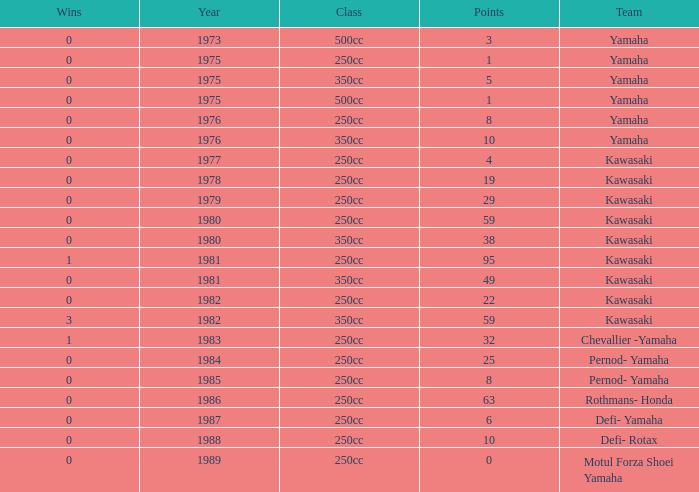How many points numbers had a class of 250cc, a year prior to 1978, Yamaha as a team, and where wins was more than 0? 0.0. 